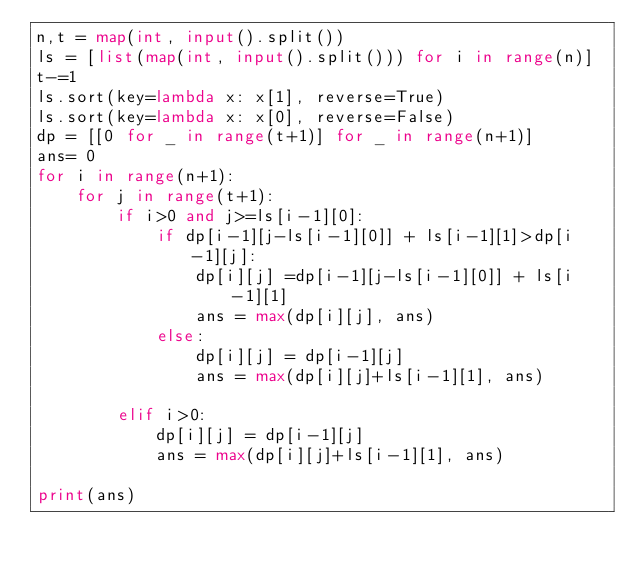<code> <loc_0><loc_0><loc_500><loc_500><_Python_>n,t = map(int, input().split())
ls = [list(map(int, input().split())) for i in range(n)]
t-=1
ls.sort(key=lambda x: x[1], reverse=True)
ls.sort(key=lambda x: x[0], reverse=False)
dp = [[0 for _ in range(t+1)] for _ in range(n+1)]
ans= 0
for i in range(n+1):
    for j in range(t+1):
        if i>0 and j>=ls[i-1][0]:
            if dp[i-1][j-ls[i-1][0]] + ls[i-1][1]>dp[i-1][j]:
                dp[i][j] =dp[i-1][j-ls[i-1][0]] + ls[i-1][1]
                ans = max(dp[i][j], ans)
            else:
                dp[i][j] = dp[i-1][j]
                ans = max(dp[i][j]+ls[i-1][1], ans)

        elif i>0:
            dp[i][j] = dp[i-1][j]
            ans = max(dp[i][j]+ls[i-1][1], ans)

print(ans)</code> 